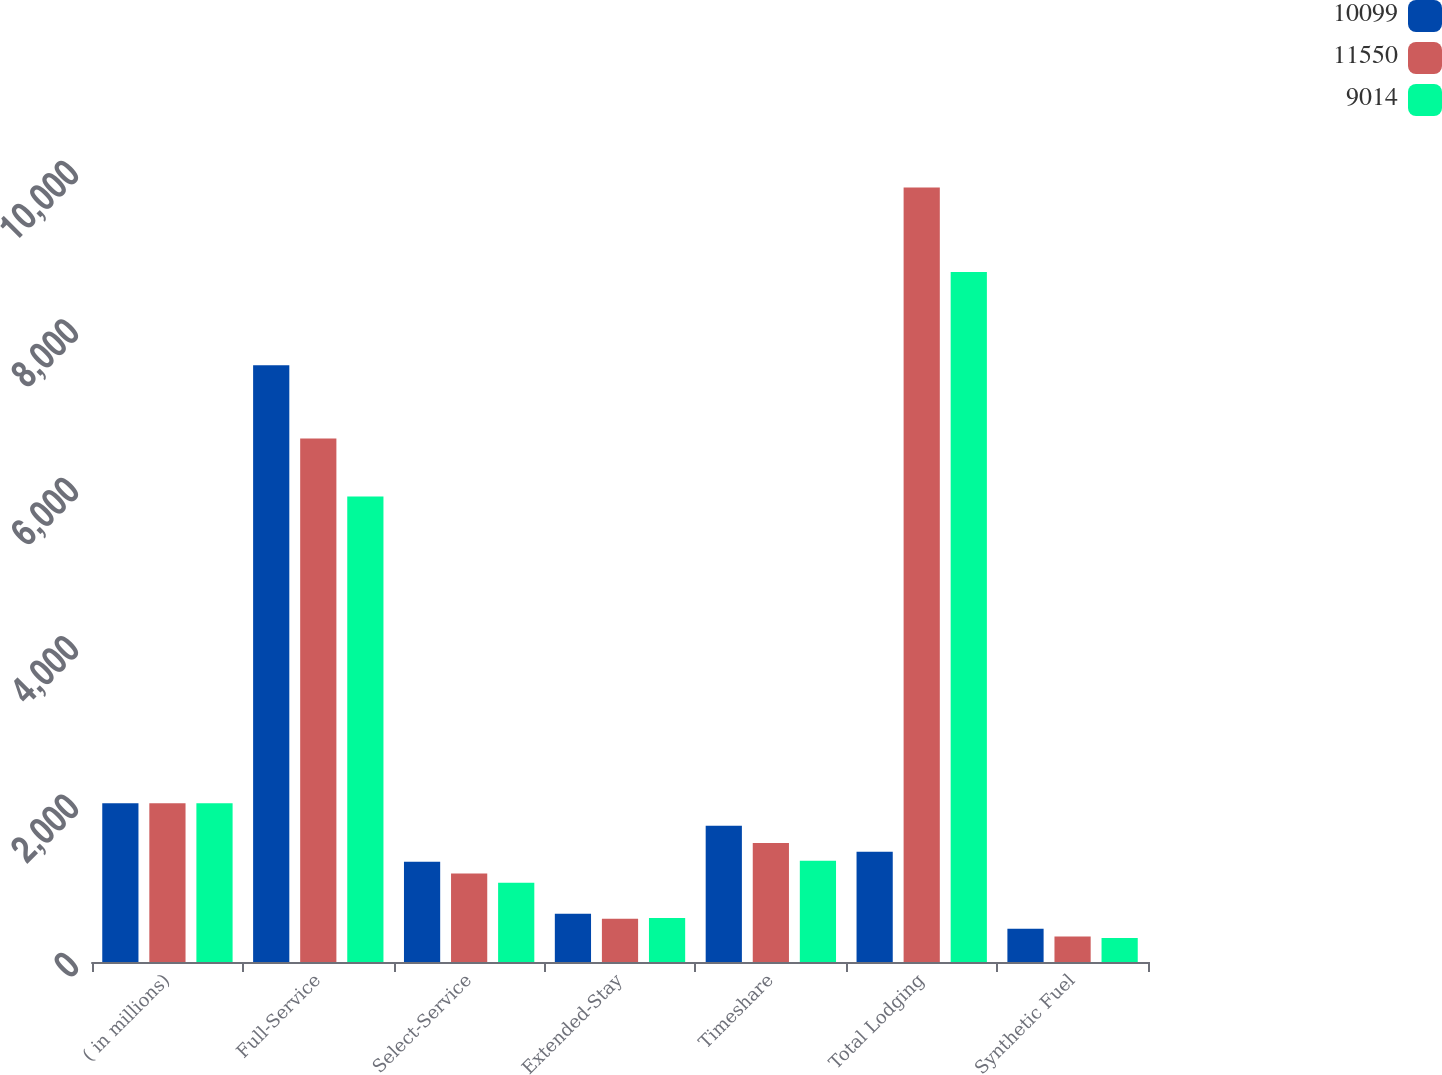Convert chart. <chart><loc_0><loc_0><loc_500><loc_500><stacked_bar_chart><ecel><fcel>( in millions)<fcel>Full-Service<fcel>Select-Service<fcel>Extended-Stay<fcel>Timeshare<fcel>Total Lodging<fcel>Synthetic Fuel<nl><fcel>10099<fcel>2005<fcel>7535<fcel>1265<fcel>608<fcel>1721<fcel>1390.5<fcel>421<nl><fcel>11550<fcel>2004<fcel>6611<fcel>1118<fcel>547<fcel>1502<fcel>9778<fcel>321<nl><fcel>9014<fcel>2003<fcel>5876<fcel>1000<fcel>557<fcel>1279<fcel>8712<fcel>302<nl></chart> 